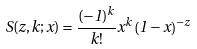<formula> <loc_0><loc_0><loc_500><loc_500>S ( z , k ; x ) = \frac { ( - 1 ) ^ { k } } { k ! } x ^ { k } \left ( 1 - x \right ) ^ { - z }</formula> 